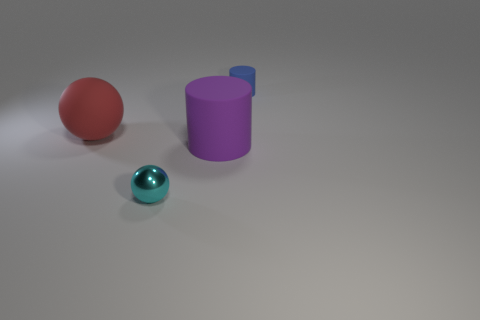There is a large object to the right of the large red rubber sphere; what is its shape? The large object to the right of the large red sphere is cylindrical in shape, with its circular base parallel to the ground. It appears to be a solid, three-dimensional object with smooth surfaces and a discernible round edge at the top, consistent with the characteristics of a cylinder. 